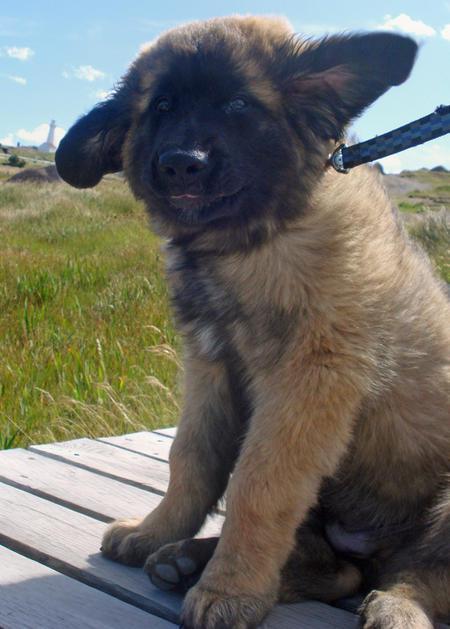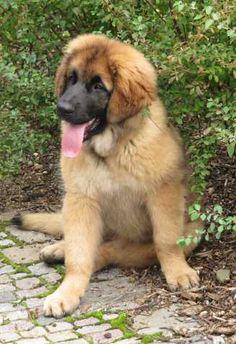The first image is the image on the left, the second image is the image on the right. Analyze the images presented: Is the assertion "An image features one dog reclining with front paws extended forward." valid? Answer yes or no. No. The first image is the image on the left, the second image is the image on the right. For the images displayed, is the sentence "The dog in the left photo has its tongue out." factually correct? Answer yes or no. No. 